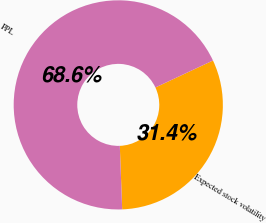<chart> <loc_0><loc_0><loc_500><loc_500><pie_chart><fcel>Expected stock volatility<fcel>PPL<nl><fcel>31.38%<fcel>68.62%<nl></chart> 